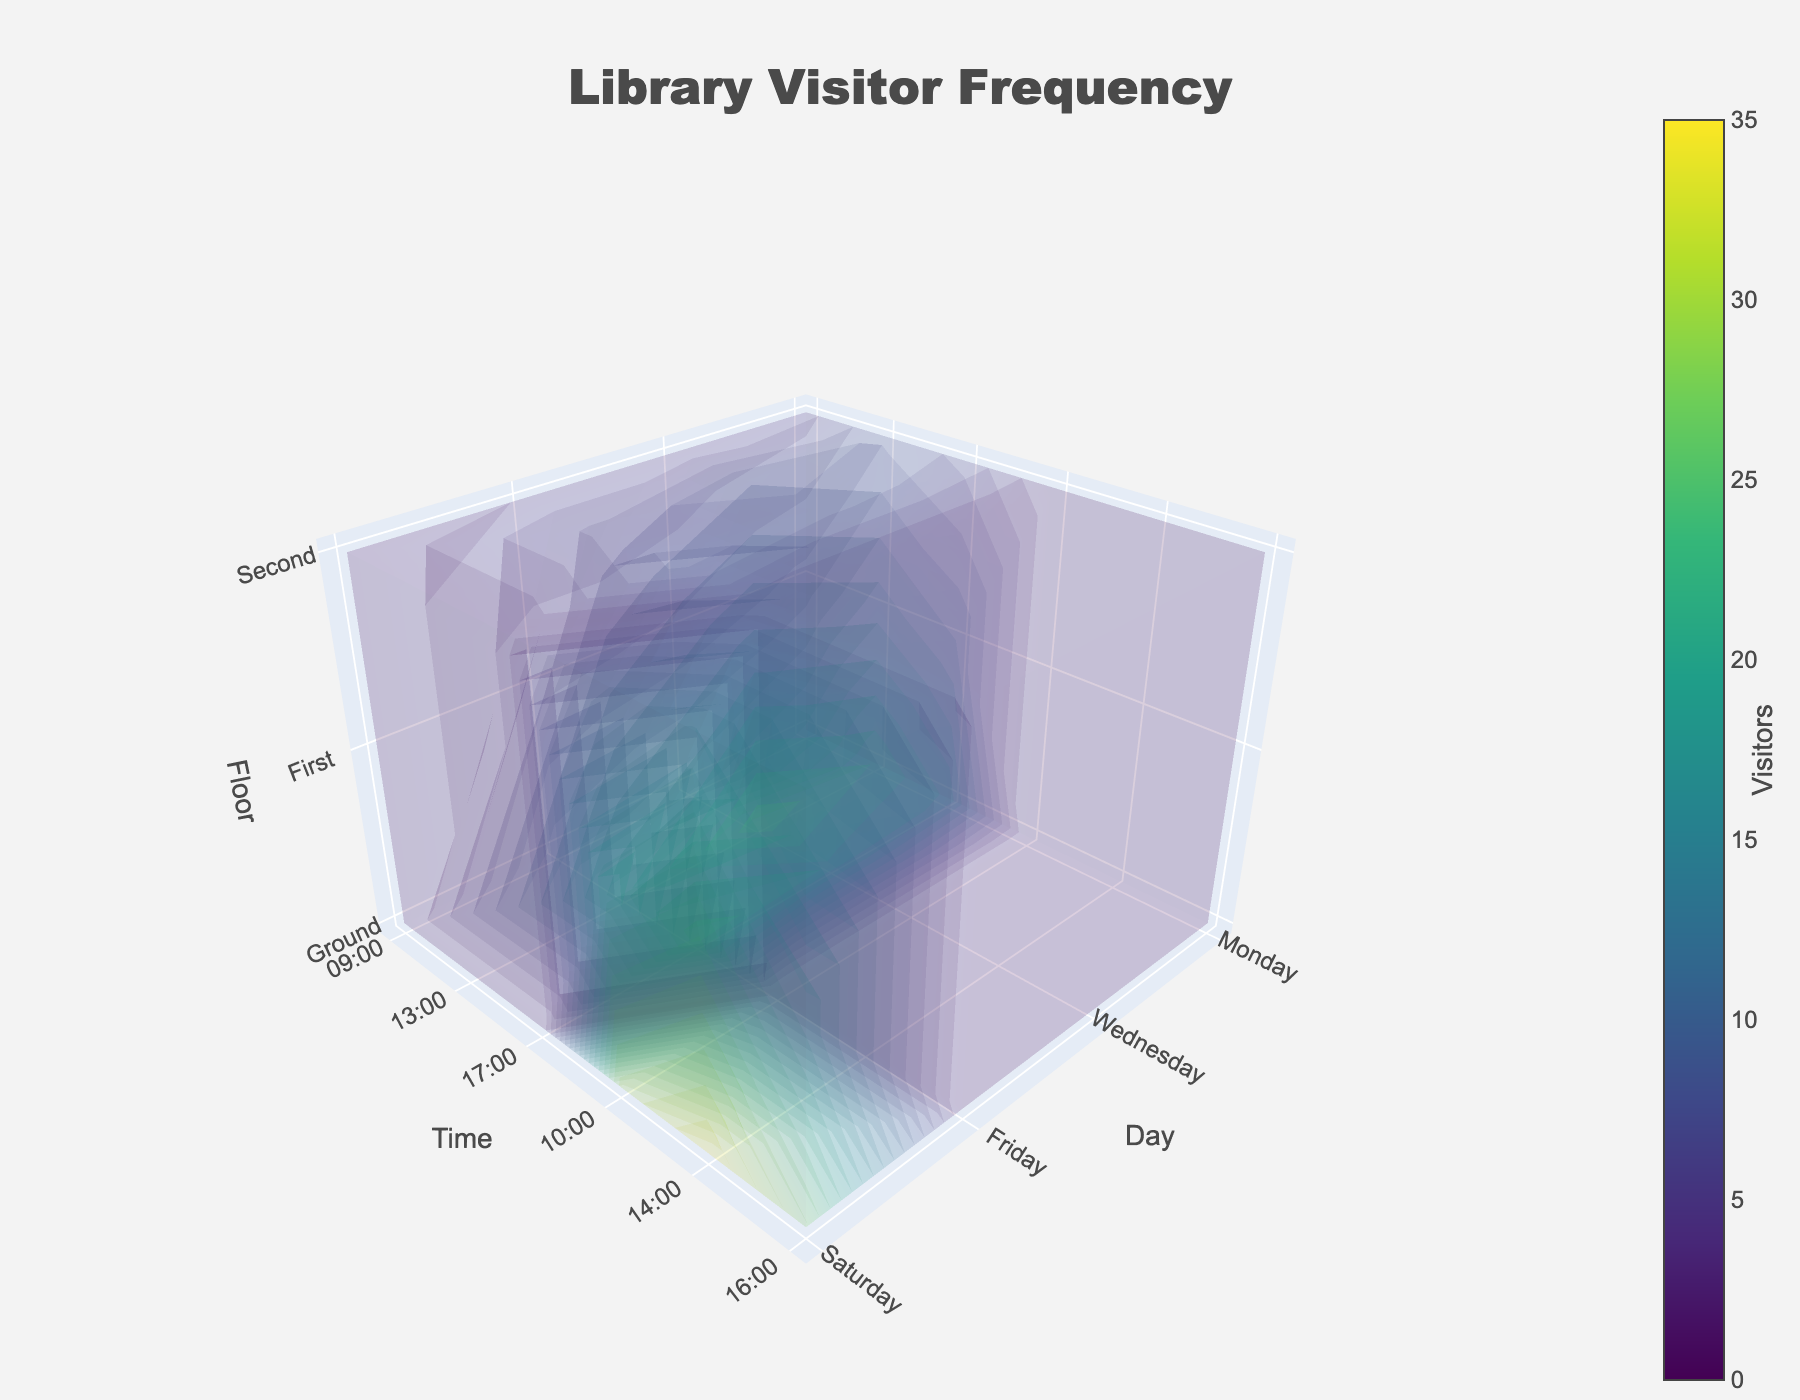What's the title of the figure? The title is the text positioned at the top and center of the figure in larger and bold font. From the layout settings, the title is 'Library Visitor Frequency'.
Answer: Library Visitor Frequency Which days are represented on the x-axis? The x-axis has labeled tick values corresponding to the unique days in the dataset. They are visible as tick text on the x-axis. The days are Monday, Wednesday, Friday, and Saturday.
Answer: Monday, Wednesday, Friday, Saturday How many layers (floor levels) are plotted on the z-axis? The z-axis represents the floor levels and its tick values indicate the number of unique floor levels. From the data and visualization, there are three floor levels: Ground, First, and Second.
Answer: Three At what time is the highest number of visitors recorded? The peak value can be assessed by observing the color intensity scale, particularly the highest value, 35, on the color bar. By locating this peak value on the plot, we see it occurs on Saturday at 14:00 on the Ground floor.
Answer: Saturday at 14:00 Which floor has the least number of visitors on a typical weekday morning at 09:00? By examining the 3D grid at 09:00 for Monday, Wednesday, and Friday, the Second floor consistently shows the smallest visitor counts.
Answer: Second What's the total number of visitors across all floors on Monday at 13:00? Sum the visitors from each floor at 13:00 on Monday: Ground (22) + First (14) + Second (7). Calculation: 22 + 14 + 7 = 43
Answer: 43 Compare the visitor frequency on the Ground floor between Wednesday and Friday at 17:00. Look up the visitor counts for the Ground floor at 17:00 on both days. Wednesday has 20 visitors, and Friday has 23. Thus, Friday has more visitors than Wednesday.
Answer: Friday has more visitors Does the trend of visitor frequency change from morning to evening on any given weekday? Analyze the change in visitor counts from 09:00 to 17:00 across Monday, Wednesday, and Friday. Trends can be inferred from differences in color intensities. Typically, visitor frequency increases from morning to early afternoon and decreases toward the evening.
Answer: Yes, it increases and then decreases On which day is the First floor busiest and at what time? Identify peak values on the First floor by inspecting each day's intervals. The highest value for the First floor is 25 visitors, occurring on Saturday at 14:00.
Answer: Saturday at 14:00 